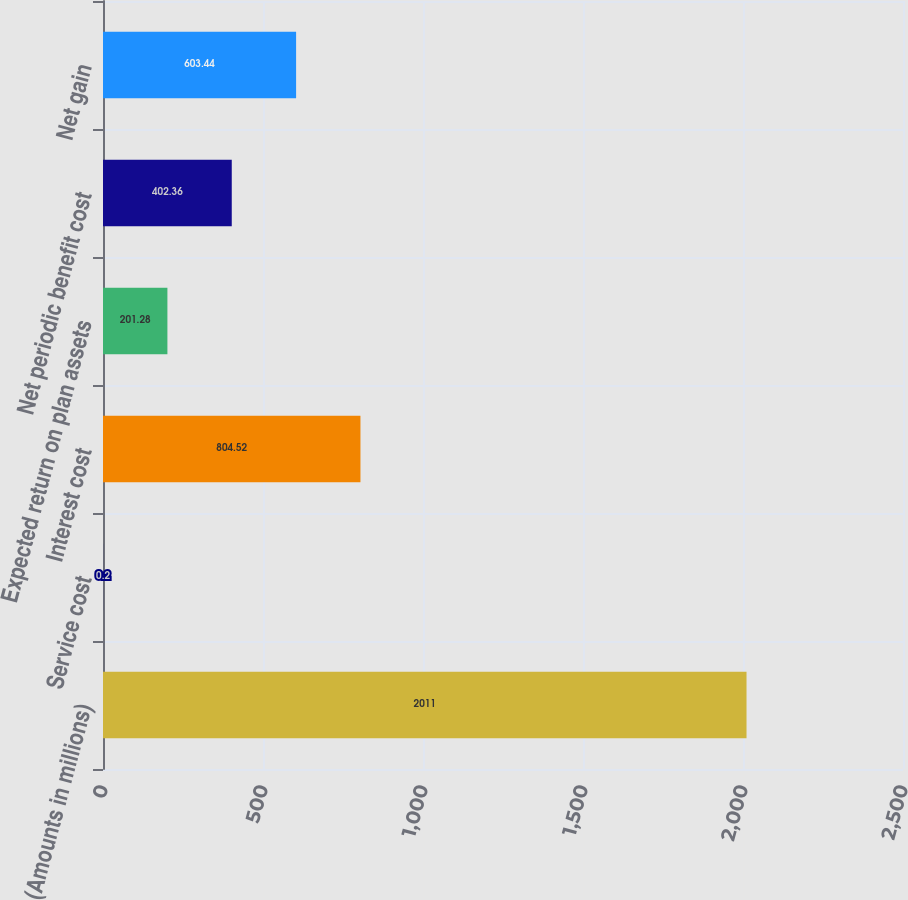Convert chart to OTSL. <chart><loc_0><loc_0><loc_500><loc_500><bar_chart><fcel>(Amounts in millions)<fcel>Service cost<fcel>Interest cost<fcel>Expected return on plan assets<fcel>Net periodic benefit cost<fcel>Net gain<nl><fcel>2011<fcel>0.2<fcel>804.52<fcel>201.28<fcel>402.36<fcel>603.44<nl></chart> 